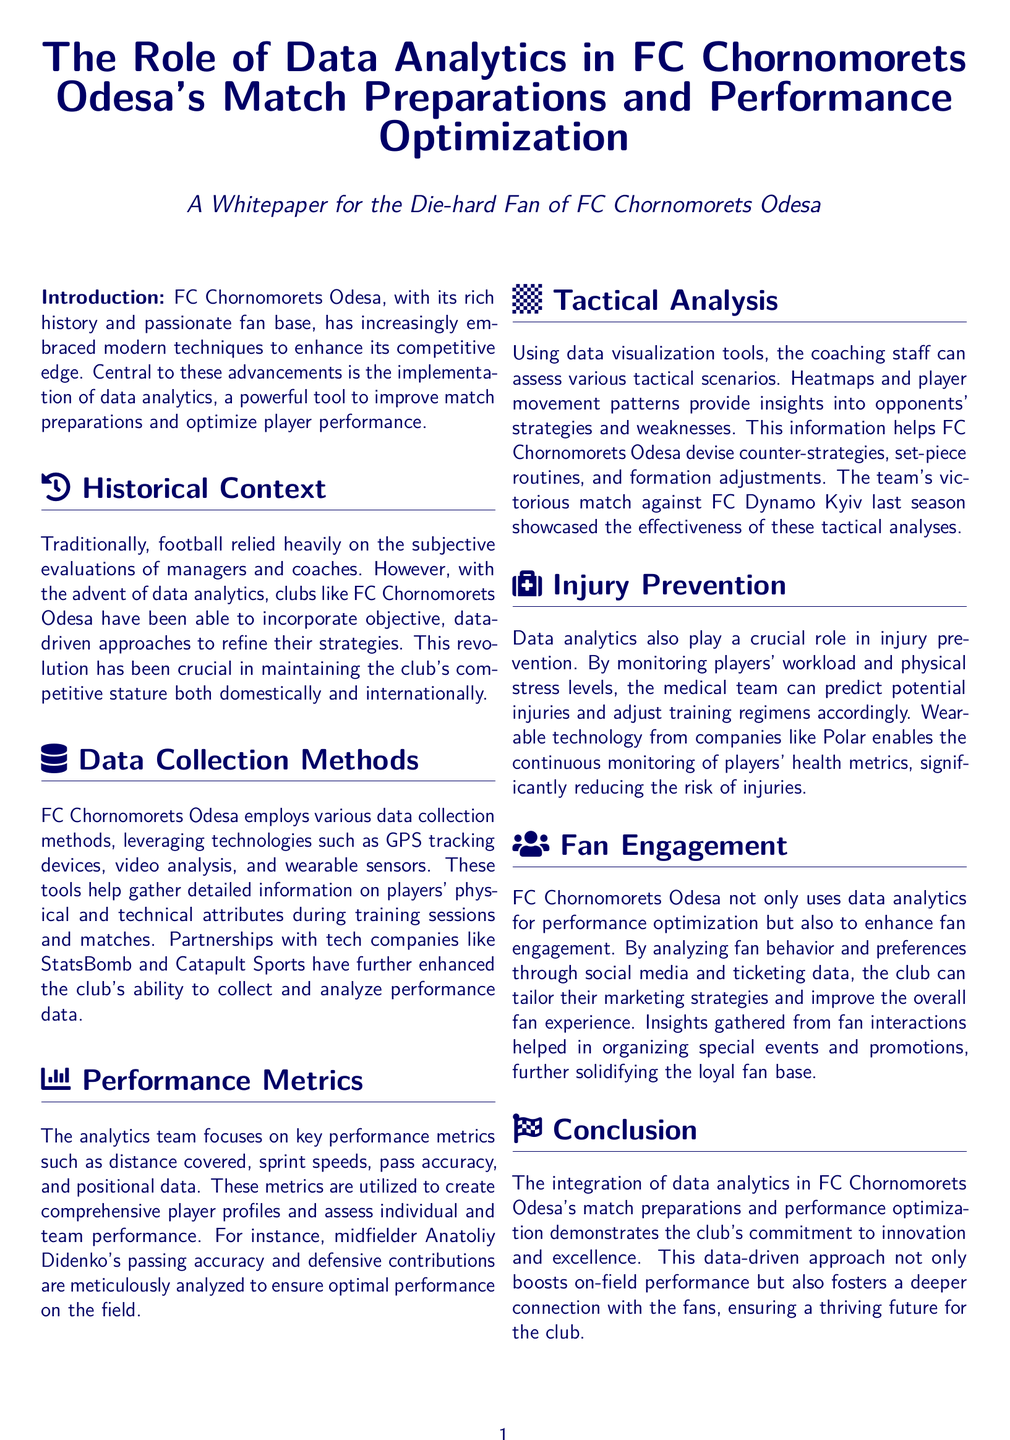What technology is used for data collection? The document mentions technologies such as GPS tracking devices, video analysis, and wearable sensors as methods used for data collection.
Answer: GPS tracking devices, video analysis, wearable sensors Which club did FC Chornomorets Odesa defeat using tactical analyses? The document states that the team showcased the effectiveness of their tactical analyses in a victorious match against FC Dynamo Kyiv.
Answer: FC Dynamo Kyiv Who is mentioned as a player analyzed for passing accuracy? The document specifies midfielder Anatoliy Didenko being analyzed for his passing accuracy and defensive contributions.
Answer: Anatoliy Didenko What is the role of data analytics in injury prevention? The document states that data analytics help predict potential injuries by monitoring players' workload and physical stress levels.
Answer: Predict potential injuries What color is used for the document's main text? The main text color in the document is dark blue as defined in the styling.
Answer: Dark blue What did FC Chornomorets Odesa analyze to enhance fan engagement? The document mentions that the club analyzes fan behavior and preferences through social media and ticketing data for better engagement.
Answer: Fan behavior and preferences What is the central theme of the whitepaper? The document primarily discusses the integration of data analytics in match preparations and performance optimization for the club.
Answer: Data analytics How does data analytics contribute to performance improvement? The document describes that by utilizing performance metrics, the club can assess individual and team performance to enhance capabilities.
Answer: Assess individual and team performance 